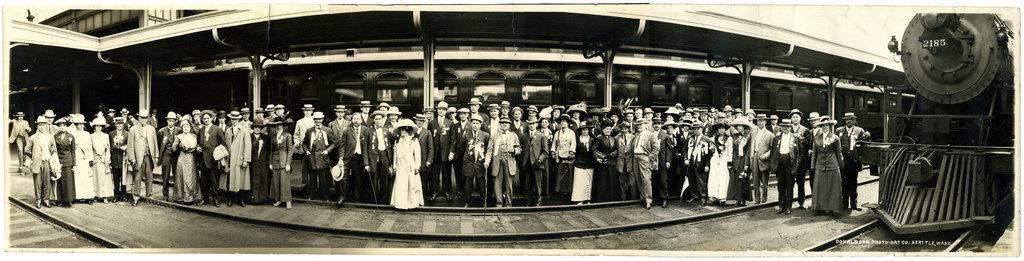In one or two sentences, can you explain what this image depicts? In this image we can see a group of people wearing dress are standing on the ground. Some persons are wearing hats and holding sticks in their hands. To the right side of the image we can see a locomotive on the track. In the background, we can see a shed, group of poles and a building with windows. 